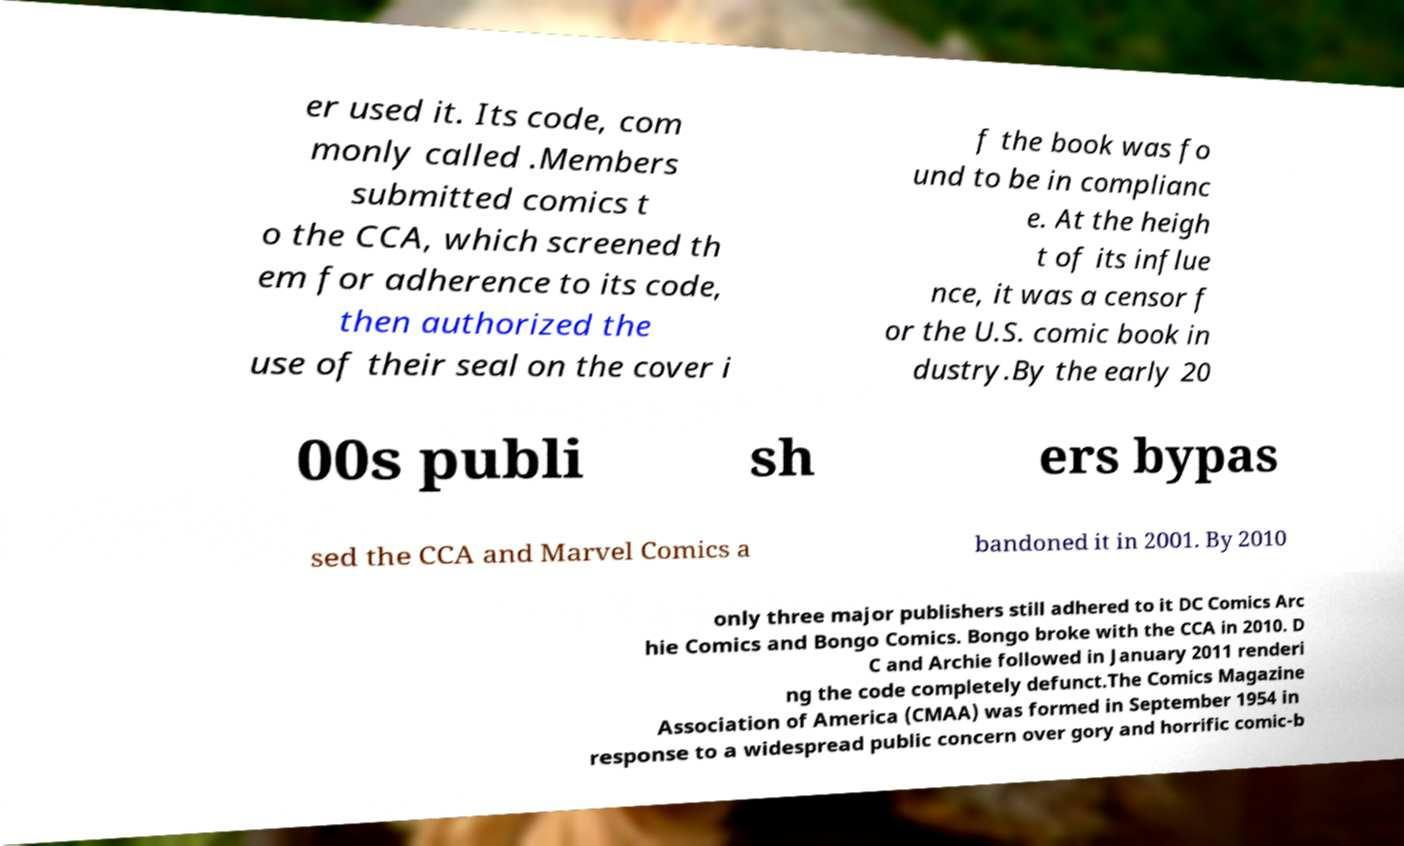Can you read and provide the text displayed in the image?This photo seems to have some interesting text. Can you extract and type it out for me? er used it. Its code, com monly called .Members submitted comics t o the CCA, which screened th em for adherence to its code, then authorized the use of their seal on the cover i f the book was fo und to be in complianc e. At the heigh t of its influe nce, it was a censor f or the U.S. comic book in dustry.By the early 20 00s publi sh ers bypas sed the CCA and Marvel Comics a bandoned it in 2001. By 2010 only three major publishers still adhered to it DC Comics Arc hie Comics and Bongo Comics. Bongo broke with the CCA in 2010. D C and Archie followed in January 2011 renderi ng the code completely defunct.The Comics Magazine Association of America (CMAA) was formed in September 1954 in response to a widespread public concern over gory and horrific comic-b 